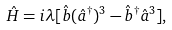Convert formula to latex. <formula><loc_0><loc_0><loc_500><loc_500>\hat { H } = i \lambda [ \hat { b } ( \hat { a } ^ { \dagger } ) ^ { 3 } - \hat { b } ^ { \dagger } \hat { a } ^ { 3 } ] ,</formula> 